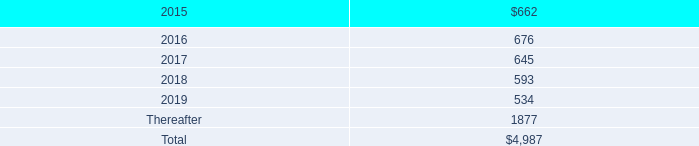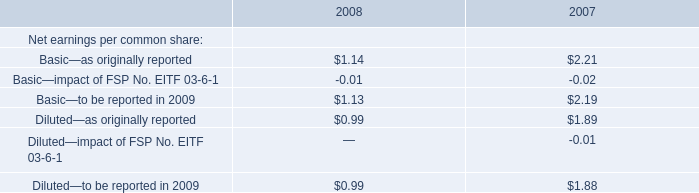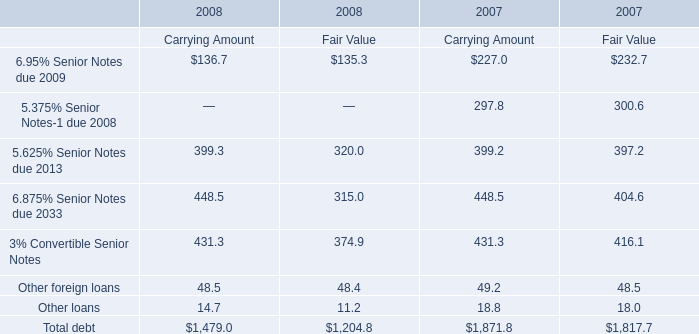In the year where Fair Value for 3% Convertible Senior Notes is the lowest, what's the growth rate of Fair Value for 6.875% Senior Notes due 2033? 
Computations: ((315.0 - 404.6) / 404.6)
Answer: -0.22145. 